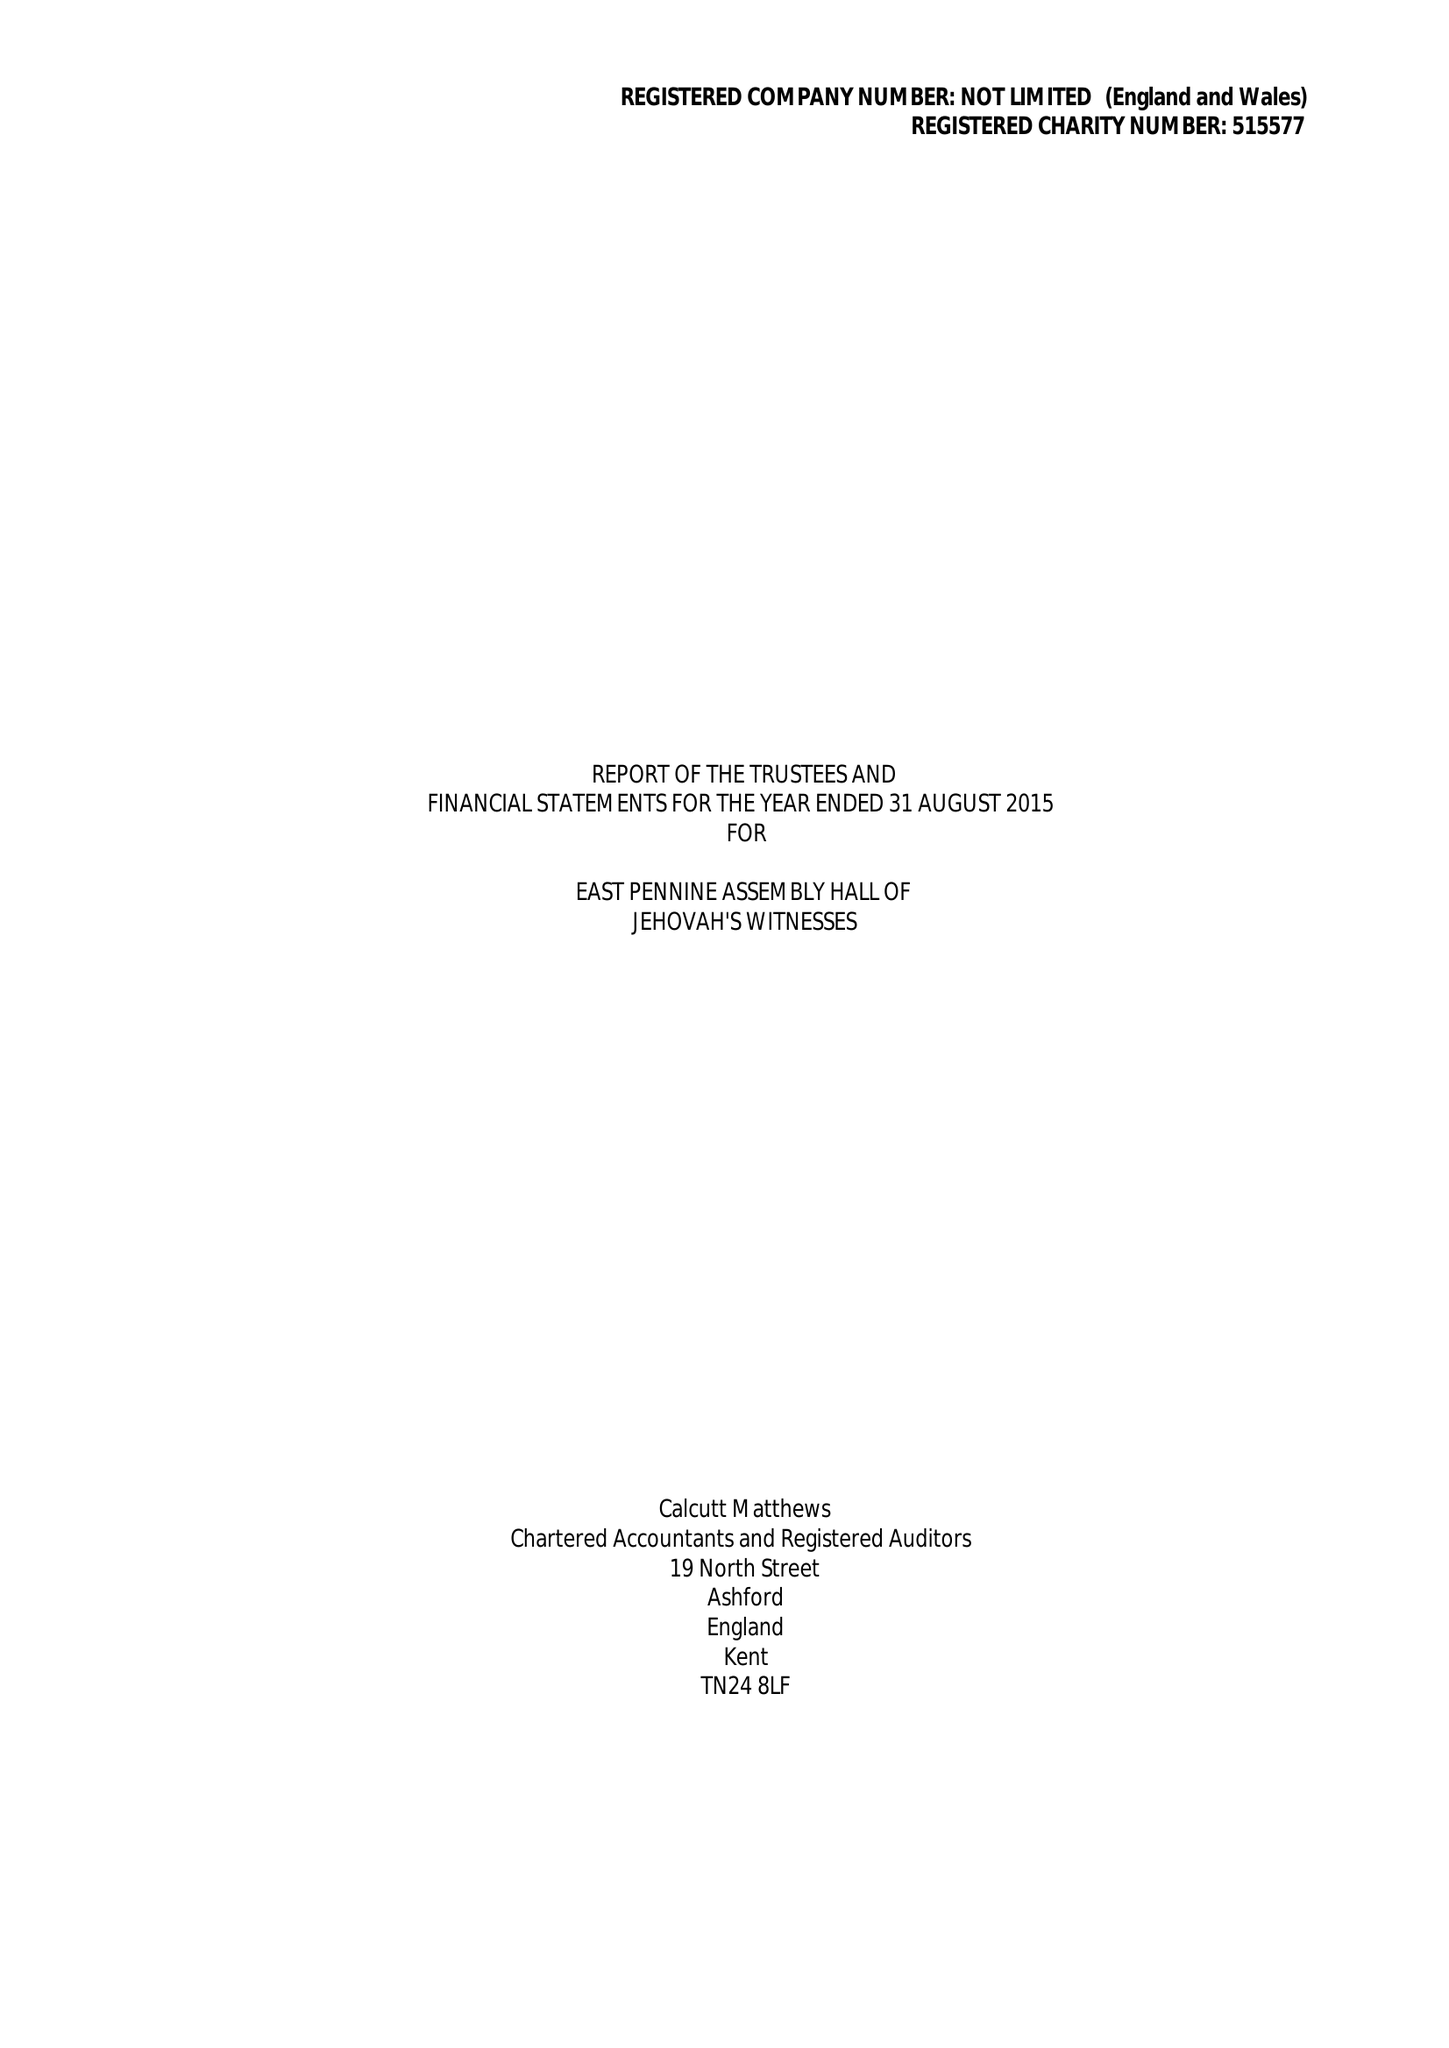What is the value for the address__post_town?
Answer the question using a single word or phrase. ROTHERHAM 